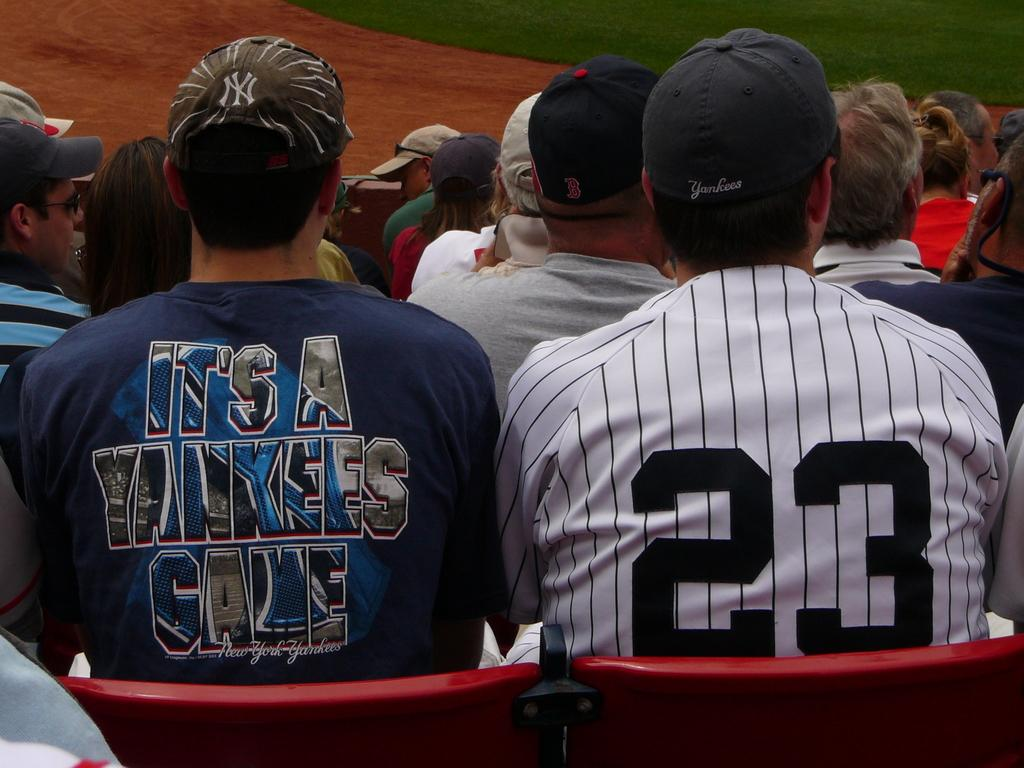<image>
Offer a succinct explanation of the picture presented. A man in a shirt that says It's a Yankees game sits in the seats at a baseball game. 